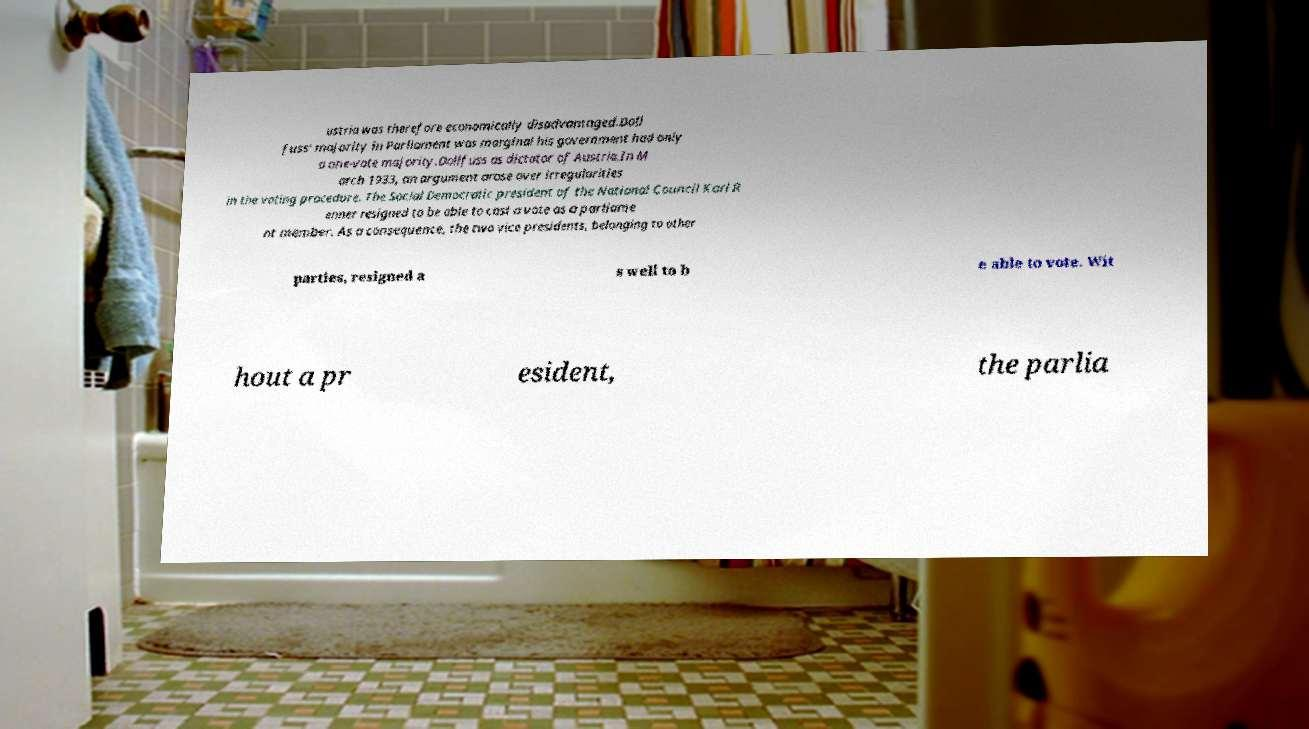Could you extract and type out the text from this image? ustria was therefore economically disadvantaged.Doll fuss' majority in Parliament was marginal his government had only a one-vote majority.Dollfuss as dictator of Austria.In M arch 1933, an argument arose over irregularities in the voting procedure. The Social Democratic president of the National Council Karl R enner resigned to be able to cast a vote as a parliame nt member. As a consequence, the two vice presidents, belonging to other parties, resigned a s well to b e able to vote. Wit hout a pr esident, the parlia 